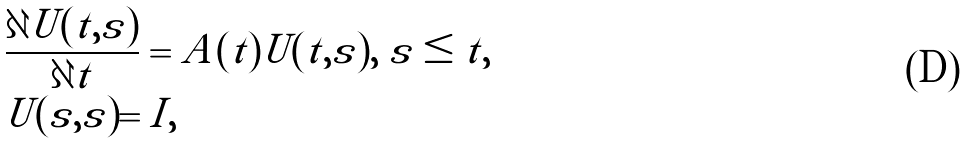<formula> <loc_0><loc_0><loc_500><loc_500>& \frac { \partial U ( t , s ) } { \partial t } = A ( t ) U ( t , s ) , \ s \leq t , \\ & U ( s , s ) = I ,</formula> 